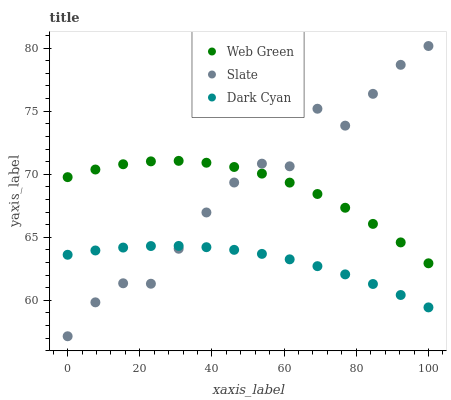Does Dark Cyan have the minimum area under the curve?
Answer yes or no. Yes. Does Slate have the maximum area under the curve?
Answer yes or no. Yes. Does Web Green have the minimum area under the curve?
Answer yes or no. No. Does Web Green have the maximum area under the curve?
Answer yes or no. No. Is Dark Cyan the smoothest?
Answer yes or no. Yes. Is Slate the roughest?
Answer yes or no. Yes. Is Web Green the smoothest?
Answer yes or no. No. Is Web Green the roughest?
Answer yes or no. No. Does Slate have the lowest value?
Answer yes or no. Yes. Does Web Green have the lowest value?
Answer yes or no. No. Does Slate have the highest value?
Answer yes or no. Yes. Does Web Green have the highest value?
Answer yes or no. No. Is Dark Cyan less than Web Green?
Answer yes or no. Yes. Is Web Green greater than Dark Cyan?
Answer yes or no. Yes. Does Dark Cyan intersect Slate?
Answer yes or no. Yes. Is Dark Cyan less than Slate?
Answer yes or no. No. Is Dark Cyan greater than Slate?
Answer yes or no. No. Does Dark Cyan intersect Web Green?
Answer yes or no. No. 